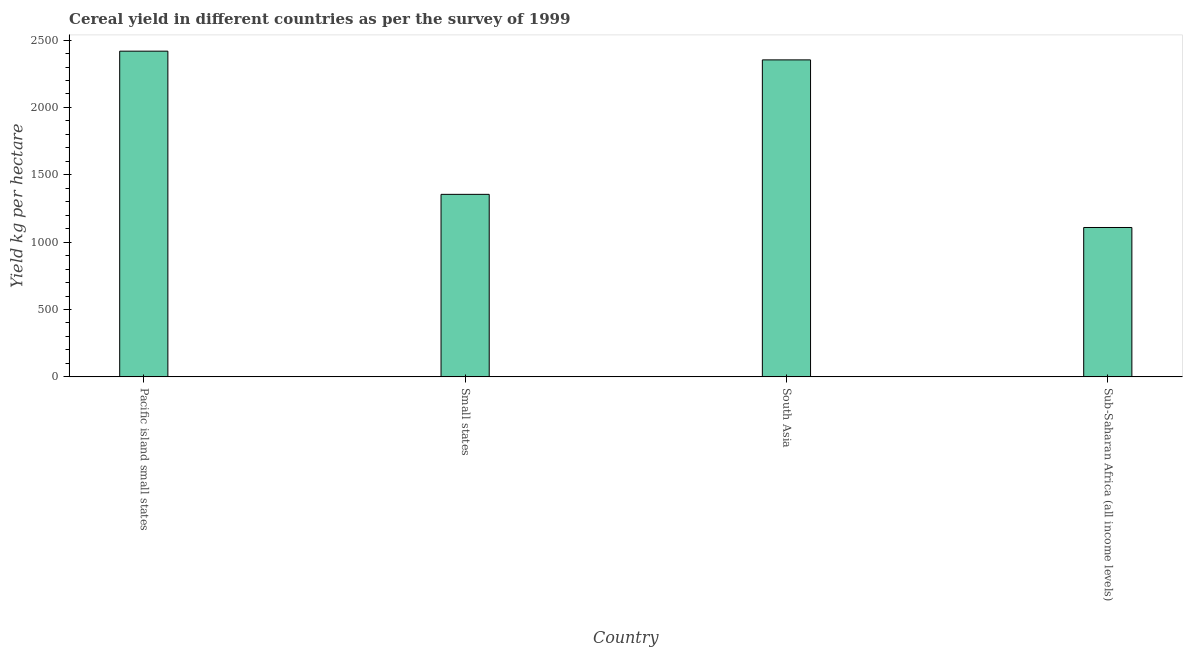Does the graph contain any zero values?
Your answer should be compact. No. Does the graph contain grids?
Offer a terse response. No. What is the title of the graph?
Your answer should be compact. Cereal yield in different countries as per the survey of 1999. What is the label or title of the X-axis?
Ensure brevity in your answer.  Country. What is the label or title of the Y-axis?
Make the answer very short. Yield kg per hectare. What is the cereal yield in Pacific island small states?
Give a very brief answer. 2417.95. Across all countries, what is the maximum cereal yield?
Provide a short and direct response. 2417.95. Across all countries, what is the minimum cereal yield?
Keep it short and to the point. 1108.91. In which country was the cereal yield maximum?
Give a very brief answer. Pacific island small states. In which country was the cereal yield minimum?
Your answer should be very brief. Sub-Saharan Africa (all income levels). What is the sum of the cereal yield?
Give a very brief answer. 7235.04. What is the difference between the cereal yield in Small states and South Asia?
Provide a succinct answer. -998.32. What is the average cereal yield per country?
Offer a terse response. 1808.76. What is the median cereal yield?
Ensure brevity in your answer.  1854.09. What is the ratio of the cereal yield in Small states to that in South Asia?
Your answer should be compact. 0.58. Is the cereal yield in Small states less than that in Sub-Saharan Africa (all income levels)?
Keep it short and to the point. No. What is the difference between the highest and the second highest cereal yield?
Give a very brief answer. 64.7. Is the sum of the cereal yield in Small states and Sub-Saharan Africa (all income levels) greater than the maximum cereal yield across all countries?
Keep it short and to the point. Yes. What is the difference between the highest and the lowest cereal yield?
Your response must be concise. 1309.04. Are the values on the major ticks of Y-axis written in scientific E-notation?
Provide a succinct answer. No. What is the Yield kg per hectare in Pacific island small states?
Offer a very short reply. 2417.95. What is the Yield kg per hectare in Small states?
Offer a terse response. 1354.93. What is the Yield kg per hectare in South Asia?
Provide a short and direct response. 2353.25. What is the Yield kg per hectare of Sub-Saharan Africa (all income levels)?
Offer a very short reply. 1108.91. What is the difference between the Yield kg per hectare in Pacific island small states and Small states?
Offer a very short reply. 1063.03. What is the difference between the Yield kg per hectare in Pacific island small states and South Asia?
Your answer should be compact. 64.7. What is the difference between the Yield kg per hectare in Pacific island small states and Sub-Saharan Africa (all income levels)?
Ensure brevity in your answer.  1309.04. What is the difference between the Yield kg per hectare in Small states and South Asia?
Your response must be concise. -998.32. What is the difference between the Yield kg per hectare in Small states and Sub-Saharan Africa (all income levels)?
Keep it short and to the point. 246.01. What is the difference between the Yield kg per hectare in South Asia and Sub-Saharan Africa (all income levels)?
Make the answer very short. 1244.34. What is the ratio of the Yield kg per hectare in Pacific island small states to that in Small states?
Your answer should be compact. 1.78. What is the ratio of the Yield kg per hectare in Pacific island small states to that in Sub-Saharan Africa (all income levels)?
Ensure brevity in your answer.  2.18. What is the ratio of the Yield kg per hectare in Small states to that in South Asia?
Ensure brevity in your answer.  0.58. What is the ratio of the Yield kg per hectare in Small states to that in Sub-Saharan Africa (all income levels)?
Ensure brevity in your answer.  1.22. What is the ratio of the Yield kg per hectare in South Asia to that in Sub-Saharan Africa (all income levels)?
Your answer should be very brief. 2.12. 